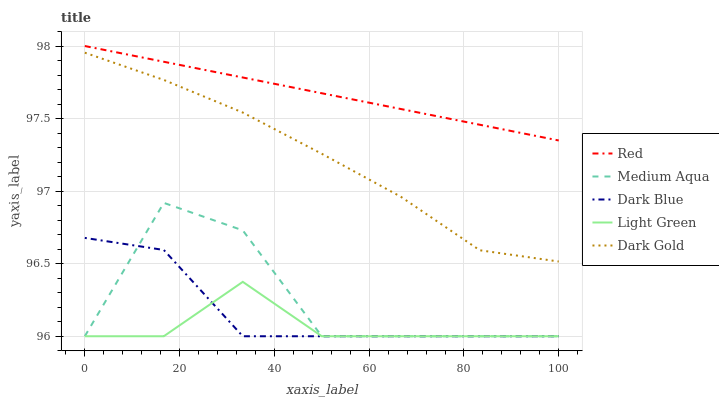Does Light Green have the minimum area under the curve?
Answer yes or no. Yes. Does Red have the maximum area under the curve?
Answer yes or no. Yes. Does Medium Aqua have the minimum area under the curve?
Answer yes or no. No. Does Medium Aqua have the maximum area under the curve?
Answer yes or no. No. Is Red the smoothest?
Answer yes or no. Yes. Is Medium Aqua the roughest?
Answer yes or no. Yes. Is Light Green the smoothest?
Answer yes or no. No. Is Light Green the roughest?
Answer yes or no. No. Does Dark Blue have the lowest value?
Answer yes or no. Yes. Does Red have the lowest value?
Answer yes or no. No. Does Red have the highest value?
Answer yes or no. Yes. Does Medium Aqua have the highest value?
Answer yes or no. No. Is Dark Blue less than Red?
Answer yes or no. Yes. Is Dark Gold greater than Dark Blue?
Answer yes or no. Yes. Does Medium Aqua intersect Light Green?
Answer yes or no. Yes. Is Medium Aqua less than Light Green?
Answer yes or no. No. Is Medium Aqua greater than Light Green?
Answer yes or no. No. Does Dark Blue intersect Red?
Answer yes or no. No. 